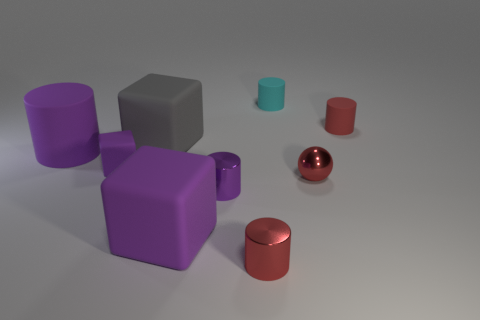Is the shape of the gray matte object the same as the purple rubber object left of the tiny purple matte block?
Your response must be concise. No. How many purple objects are the same size as the cyan cylinder?
Offer a very short reply. 2. Is the shape of the red thing behind the big purple cylinder the same as the large object that is behind the big cylinder?
Give a very brief answer. No. What shape is the small matte thing that is the same color as the metallic sphere?
Keep it short and to the point. Cylinder. There is a small matte thing to the left of the cylinder that is behind the tiny red matte object; what color is it?
Provide a short and direct response. Purple. There is a small thing that is the same shape as the big gray thing; what color is it?
Offer a very short reply. Purple. There is another purple thing that is the same shape as the tiny purple matte object; what is its size?
Your answer should be very brief. Large. What is the material of the tiny purple thing on the right side of the tiny purple matte thing?
Provide a succinct answer. Metal. Is the number of objects right of the big cylinder less than the number of cyan cylinders?
Ensure brevity in your answer.  No. What is the shape of the small red object that is in front of the big matte object that is in front of the small red sphere?
Give a very brief answer. Cylinder. 